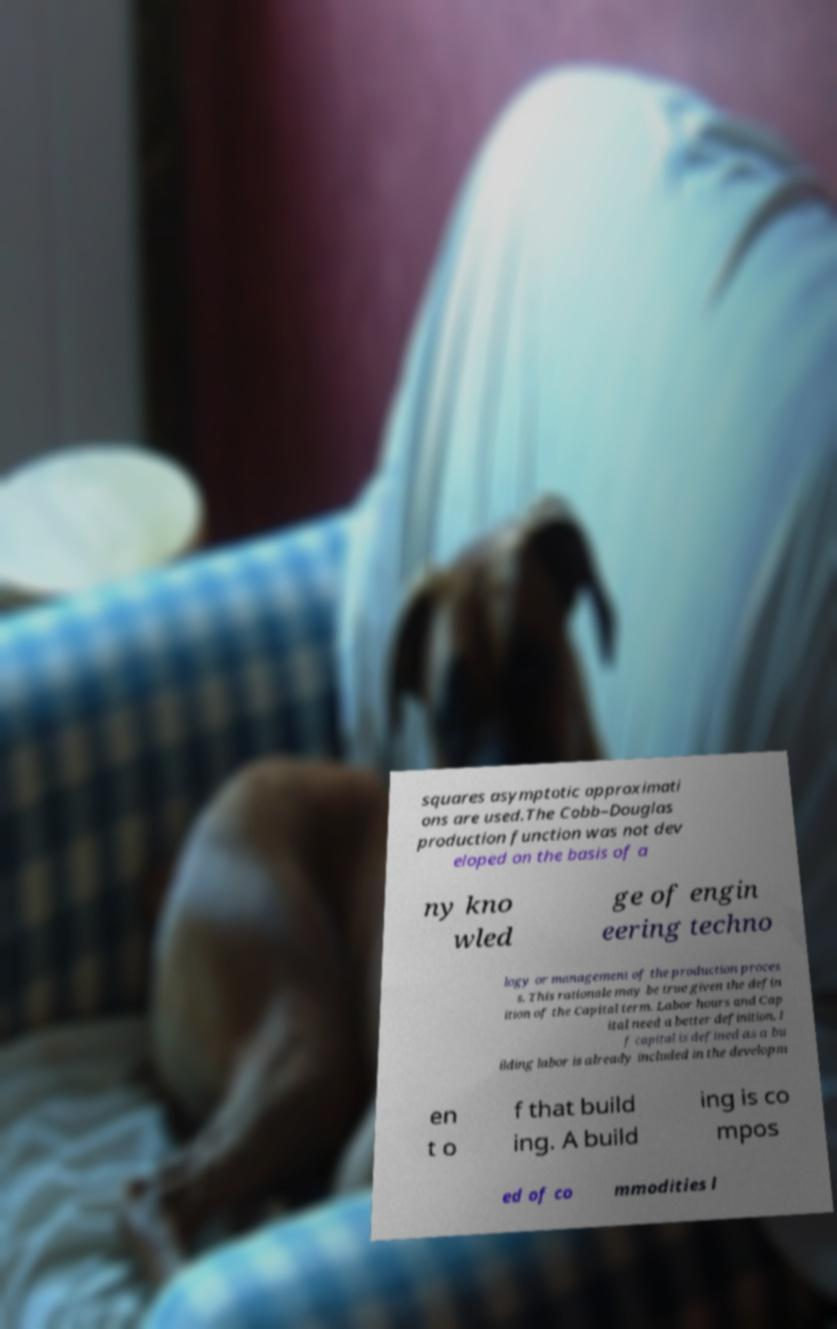I need the written content from this picture converted into text. Can you do that? squares asymptotic approximati ons are used.The Cobb–Douglas production function was not dev eloped on the basis of a ny kno wled ge of engin eering techno logy or management of the production proces s. This rationale may be true given the defin ition of the Capital term. Labor hours and Cap ital need a better definition. I f capital is defined as a bu ilding labor is already included in the developm en t o f that build ing. A build ing is co mpos ed of co mmodities l 